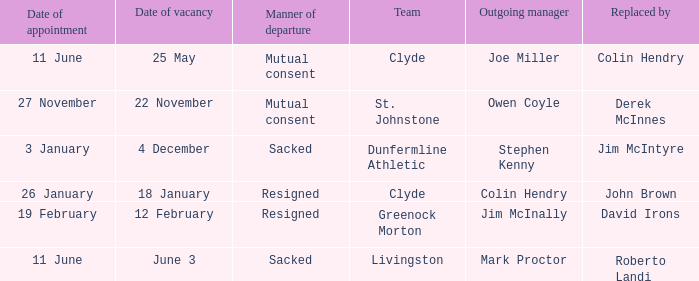Name the manner of departyre for 26 january date of appointment Resigned. 